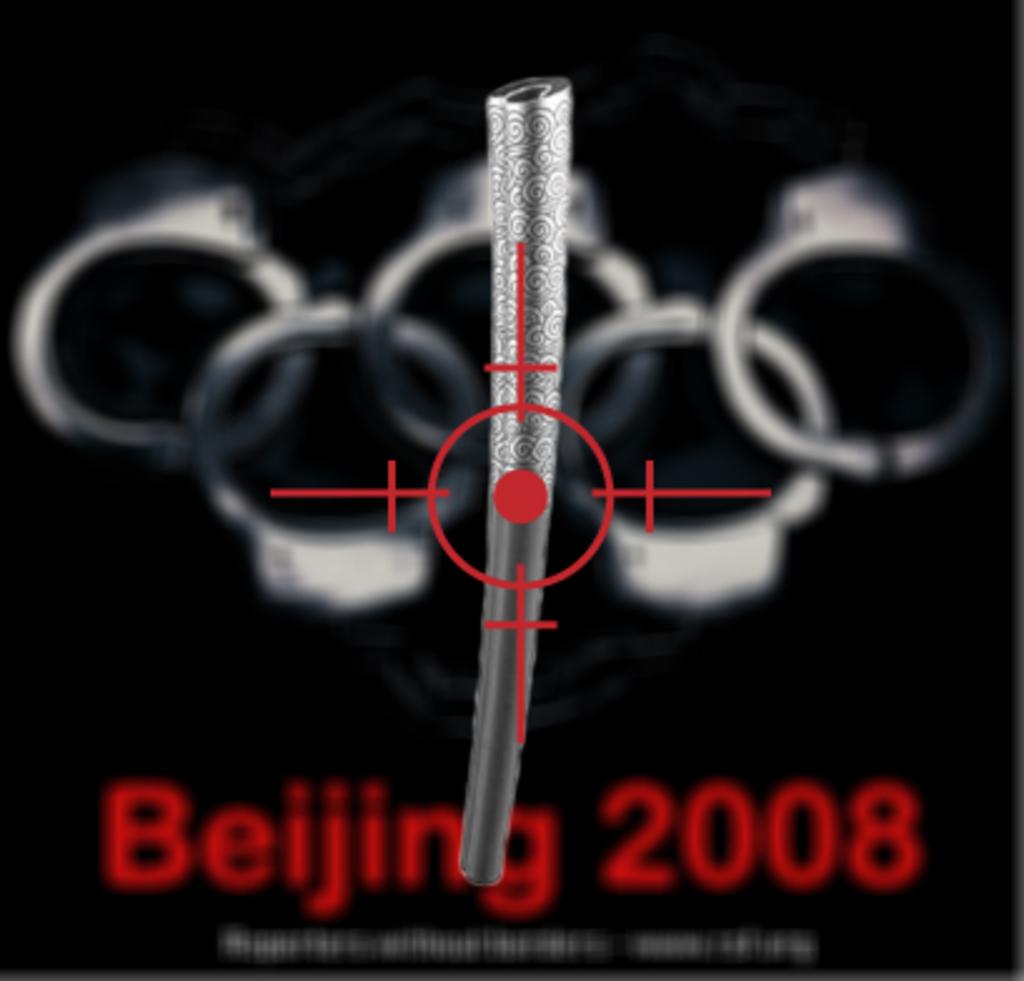What is the location?
Your answer should be very brief. Beijing. What year did this event take place in?
Make the answer very short. 2008. 